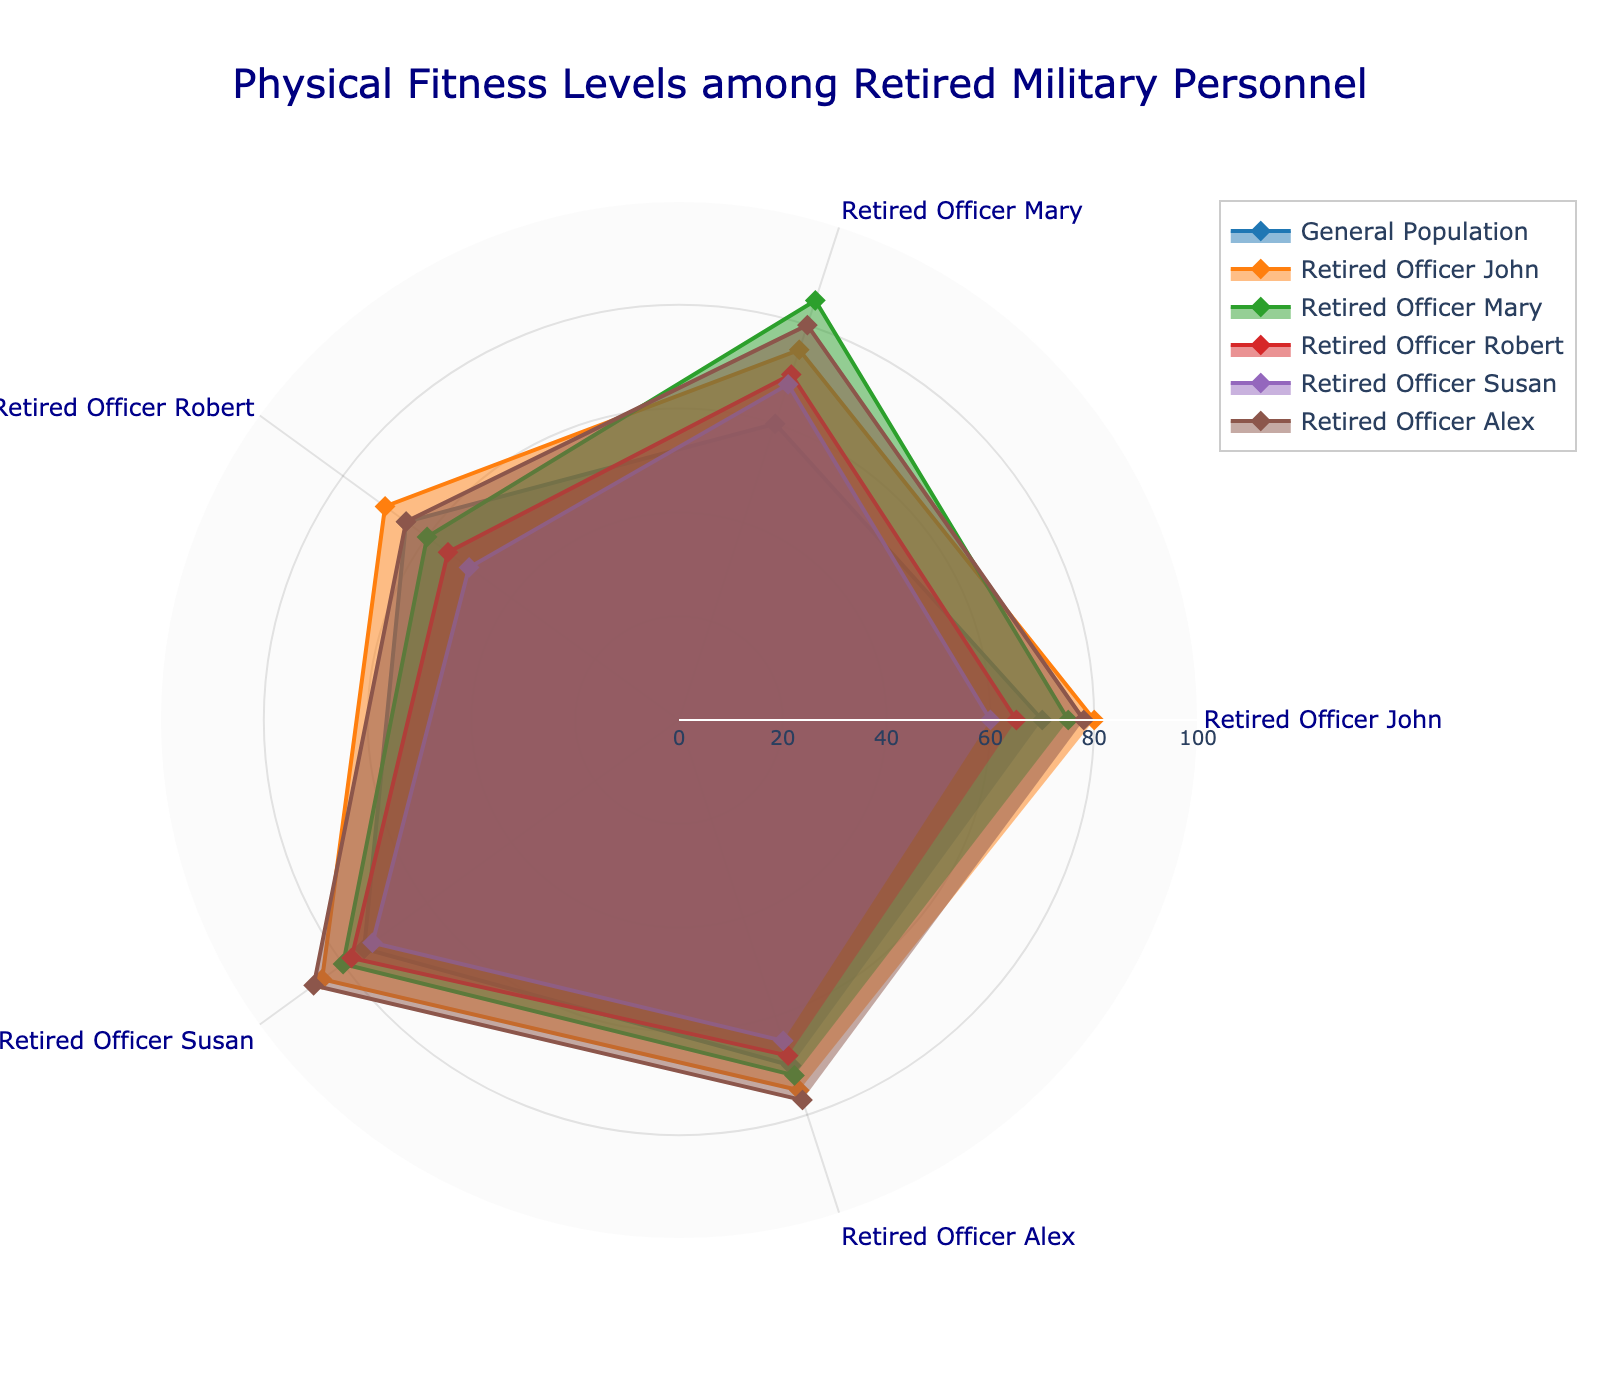What title is given to the radar chart? Look at the top of the radar chart where the title is positioned. It reads "Physical Fitness Levels among Retired Military Personnel"
Answer: Physical Fitness Levels among Retired Military Personnel Which retired officer has the highest strength value? Check the radar chart lines corresponding to each officer and compare their strength values. Retired Officer Mary has the highest strength value at 85.
Answer: Retired Officer Mary What are the dimensions measured in the radar chart? The radar chart contains axes labeled with dimensions. They are Cardiovascular Health, Strength, Flexibility, Endurance, Balance, and Mental Well-being.
Answer: Cardiovascular Health, Strength, Flexibility, Endurance, Balance, Mental Well-being Who scores the lowest in flexibility among the retired officers? Look at the flexibility values for each retired officer in the chart. Retired Officer Susan has the lowest flexibility value at 50.
Answer: Retired Officer Susan Compare the cardiovascular health between the general population and Retired Officer John. Who has better cardiovascular health? Compare the value of Cardiovascular Health for both groups in the radar chart. Retired Officer John has a higher value (80) compared to the general population (70).
Answer: Retired Officer John On average, how does the balance of retired officers compare to the general population? Calculate the average balance value of all retired officers and compare it to the general population’s balance value. The retired officers have balance values of 75, 72, 68, 65, and 77, which average to (75+72+68+65+77)/5 = 71.4, while the general population’s balance value is 70.
Answer: The retired officers have a higher average balance Which retired officer has the lowest overall scores across all six dimensions? Calculate the sum of all six dimension values for each retired officer and identify the lowest one. Retired Officer Susan’s total is 60+68+50+73+65+82 = 398, which is the lowest.
Answer: Retired Officer Susan Who scores the highest in mental well-being, and what is the value? Check the radar chart for mental well-being values. Retired Officer Alex scores the highest at 89.
Answer: Retired Officer Alex, 89 Between Retired Officer Robert and the general population, who has higher flexibility? Compare the flexibility values. The general population has a flexibility value of 65, while Retired Officer Robert has 55. Therefore, the general population has higher flexibility.
Answer: The general population 